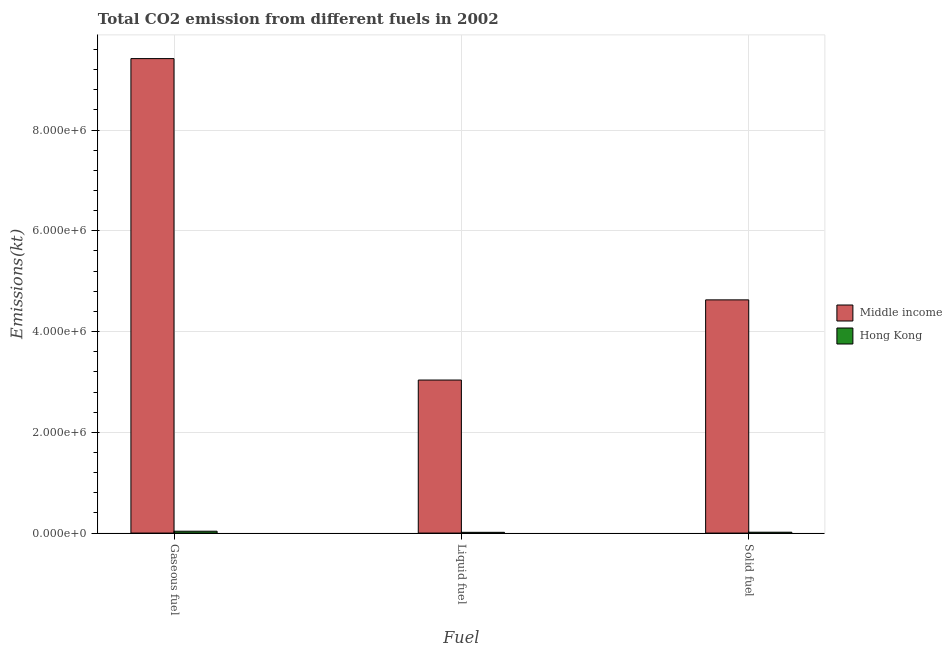How many groups of bars are there?
Your answer should be compact. 3. Are the number of bars per tick equal to the number of legend labels?
Provide a succinct answer. Yes. How many bars are there on the 1st tick from the left?
Give a very brief answer. 2. How many bars are there on the 2nd tick from the right?
Provide a succinct answer. 2. What is the label of the 3rd group of bars from the left?
Your answer should be compact. Solid fuel. What is the amount of co2 emissions from liquid fuel in Hong Kong?
Provide a short and direct response. 1.48e+04. Across all countries, what is the maximum amount of co2 emissions from liquid fuel?
Provide a succinct answer. 3.04e+06. Across all countries, what is the minimum amount of co2 emissions from solid fuel?
Keep it short and to the point. 1.70e+04. In which country was the amount of co2 emissions from gaseous fuel minimum?
Your answer should be very brief. Hong Kong. What is the total amount of co2 emissions from gaseous fuel in the graph?
Provide a succinct answer. 9.45e+06. What is the difference between the amount of co2 emissions from gaseous fuel in Middle income and that in Hong Kong?
Ensure brevity in your answer.  9.38e+06. What is the difference between the amount of co2 emissions from gaseous fuel in Middle income and the amount of co2 emissions from solid fuel in Hong Kong?
Your response must be concise. 9.40e+06. What is the average amount of co2 emissions from gaseous fuel per country?
Keep it short and to the point. 4.73e+06. What is the difference between the amount of co2 emissions from liquid fuel and amount of co2 emissions from solid fuel in Middle income?
Provide a short and direct response. -1.59e+06. In how many countries, is the amount of co2 emissions from solid fuel greater than 8000000 kt?
Provide a succinct answer. 0. What is the ratio of the amount of co2 emissions from solid fuel in Hong Kong to that in Middle income?
Offer a very short reply. 0. Is the difference between the amount of co2 emissions from liquid fuel in Middle income and Hong Kong greater than the difference between the amount of co2 emissions from solid fuel in Middle income and Hong Kong?
Keep it short and to the point. No. What is the difference between the highest and the second highest amount of co2 emissions from liquid fuel?
Provide a succinct answer. 3.02e+06. What is the difference between the highest and the lowest amount of co2 emissions from gaseous fuel?
Your answer should be compact. 9.38e+06. Is the sum of the amount of co2 emissions from liquid fuel in Hong Kong and Middle income greater than the maximum amount of co2 emissions from solid fuel across all countries?
Provide a succinct answer. No. What does the 1st bar from the left in Liquid fuel represents?
Your response must be concise. Middle income. What does the 2nd bar from the right in Solid fuel represents?
Offer a terse response. Middle income. Are all the bars in the graph horizontal?
Ensure brevity in your answer.  No. How many legend labels are there?
Ensure brevity in your answer.  2. What is the title of the graph?
Your response must be concise. Total CO2 emission from different fuels in 2002. What is the label or title of the X-axis?
Ensure brevity in your answer.  Fuel. What is the label or title of the Y-axis?
Offer a very short reply. Emissions(kt). What is the Emissions(kt) of Middle income in Gaseous fuel?
Offer a very short reply. 9.42e+06. What is the Emissions(kt) of Hong Kong in Gaseous fuel?
Give a very brief answer. 3.70e+04. What is the Emissions(kt) of Middle income in Liquid fuel?
Keep it short and to the point. 3.04e+06. What is the Emissions(kt) of Hong Kong in Liquid fuel?
Keep it short and to the point. 1.48e+04. What is the Emissions(kt) of Middle income in Solid fuel?
Offer a very short reply. 4.63e+06. What is the Emissions(kt) in Hong Kong in Solid fuel?
Make the answer very short. 1.70e+04. Across all Fuel, what is the maximum Emissions(kt) in Middle income?
Give a very brief answer. 9.42e+06. Across all Fuel, what is the maximum Emissions(kt) of Hong Kong?
Offer a terse response. 3.70e+04. Across all Fuel, what is the minimum Emissions(kt) in Middle income?
Your answer should be very brief. 3.04e+06. Across all Fuel, what is the minimum Emissions(kt) of Hong Kong?
Ensure brevity in your answer.  1.48e+04. What is the total Emissions(kt) of Middle income in the graph?
Keep it short and to the point. 1.71e+07. What is the total Emissions(kt) in Hong Kong in the graph?
Your response must be concise. 6.87e+04. What is the difference between the Emissions(kt) in Middle income in Gaseous fuel and that in Liquid fuel?
Your response must be concise. 6.38e+06. What is the difference between the Emissions(kt) of Hong Kong in Gaseous fuel and that in Liquid fuel?
Provide a short and direct response. 2.22e+04. What is the difference between the Emissions(kt) of Middle income in Gaseous fuel and that in Solid fuel?
Provide a succinct answer. 4.79e+06. What is the difference between the Emissions(kt) in Hong Kong in Gaseous fuel and that in Solid fuel?
Make the answer very short. 2.00e+04. What is the difference between the Emissions(kt) of Middle income in Liquid fuel and that in Solid fuel?
Give a very brief answer. -1.59e+06. What is the difference between the Emissions(kt) in Hong Kong in Liquid fuel and that in Solid fuel?
Offer a terse response. -2203.87. What is the difference between the Emissions(kt) of Middle income in Gaseous fuel and the Emissions(kt) of Hong Kong in Liquid fuel?
Provide a short and direct response. 9.40e+06. What is the difference between the Emissions(kt) in Middle income in Gaseous fuel and the Emissions(kt) in Hong Kong in Solid fuel?
Make the answer very short. 9.40e+06. What is the difference between the Emissions(kt) in Middle income in Liquid fuel and the Emissions(kt) in Hong Kong in Solid fuel?
Give a very brief answer. 3.02e+06. What is the average Emissions(kt) of Middle income per Fuel?
Your response must be concise. 5.69e+06. What is the average Emissions(kt) of Hong Kong per Fuel?
Provide a short and direct response. 2.29e+04. What is the difference between the Emissions(kt) of Middle income and Emissions(kt) of Hong Kong in Gaseous fuel?
Offer a very short reply. 9.38e+06. What is the difference between the Emissions(kt) in Middle income and Emissions(kt) in Hong Kong in Liquid fuel?
Your response must be concise. 3.02e+06. What is the difference between the Emissions(kt) of Middle income and Emissions(kt) of Hong Kong in Solid fuel?
Your response must be concise. 4.61e+06. What is the ratio of the Emissions(kt) in Middle income in Gaseous fuel to that in Liquid fuel?
Your response must be concise. 3.1. What is the ratio of the Emissions(kt) in Hong Kong in Gaseous fuel to that in Liquid fuel?
Your answer should be compact. 2.5. What is the ratio of the Emissions(kt) of Middle income in Gaseous fuel to that in Solid fuel?
Provide a succinct answer. 2.03. What is the ratio of the Emissions(kt) in Hong Kong in Gaseous fuel to that in Solid fuel?
Your answer should be compact. 2.17. What is the ratio of the Emissions(kt) of Middle income in Liquid fuel to that in Solid fuel?
Your answer should be very brief. 0.66. What is the ratio of the Emissions(kt) in Hong Kong in Liquid fuel to that in Solid fuel?
Your response must be concise. 0.87. What is the difference between the highest and the second highest Emissions(kt) in Middle income?
Your response must be concise. 4.79e+06. What is the difference between the highest and the second highest Emissions(kt) in Hong Kong?
Your answer should be compact. 2.00e+04. What is the difference between the highest and the lowest Emissions(kt) in Middle income?
Your response must be concise. 6.38e+06. What is the difference between the highest and the lowest Emissions(kt) in Hong Kong?
Give a very brief answer. 2.22e+04. 